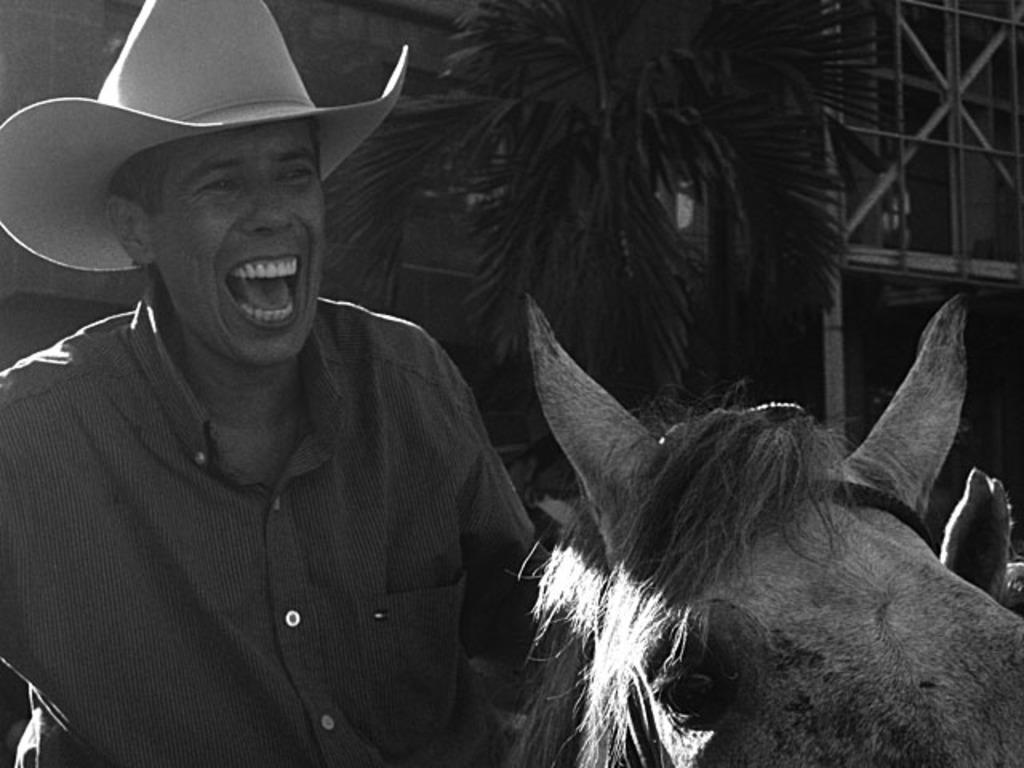Please provide a concise description of this image. In this image i can see a person wearing hat and at the right side of the image there is a horse and at the background of the image there are trees and building. 